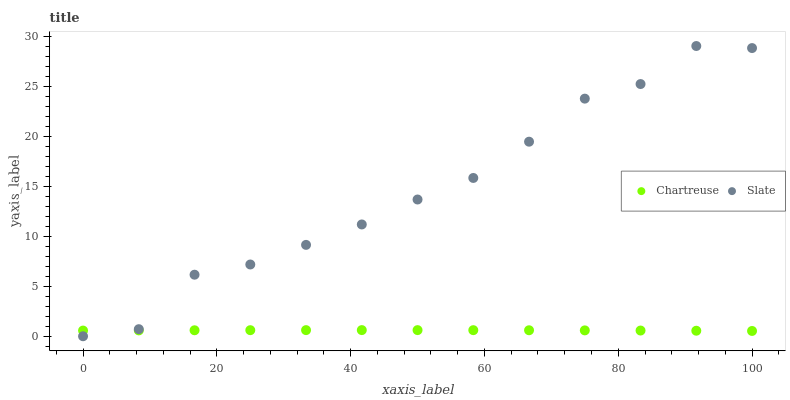Does Chartreuse have the minimum area under the curve?
Answer yes or no. Yes. Does Slate have the maximum area under the curve?
Answer yes or no. Yes. Does Slate have the minimum area under the curve?
Answer yes or no. No. Is Chartreuse the smoothest?
Answer yes or no. Yes. Is Slate the roughest?
Answer yes or no. Yes. Is Slate the smoothest?
Answer yes or no. No. Does Slate have the lowest value?
Answer yes or no. Yes. Does Slate have the highest value?
Answer yes or no. Yes. Does Chartreuse intersect Slate?
Answer yes or no. Yes. Is Chartreuse less than Slate?
Answer yes or no. No. Is Chartreuse greater than Slate?
Answer yes or no. No. 